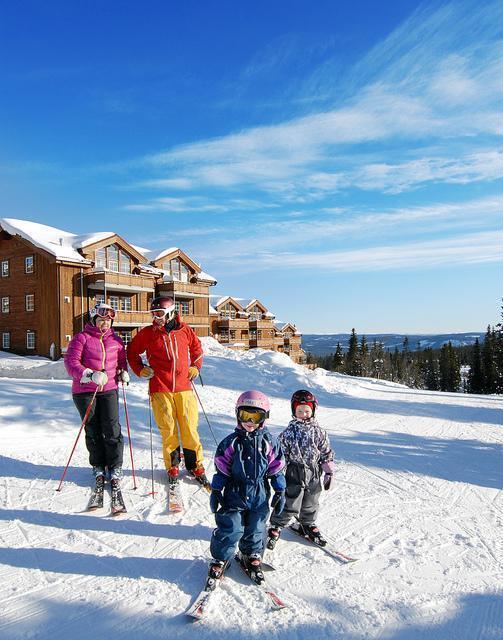Who are the adults standing behind the children?
From the following set of four choices, select the accurate answer to respond to the question.
Options: Coaches, teachers, neighbors, parents. Parents. 